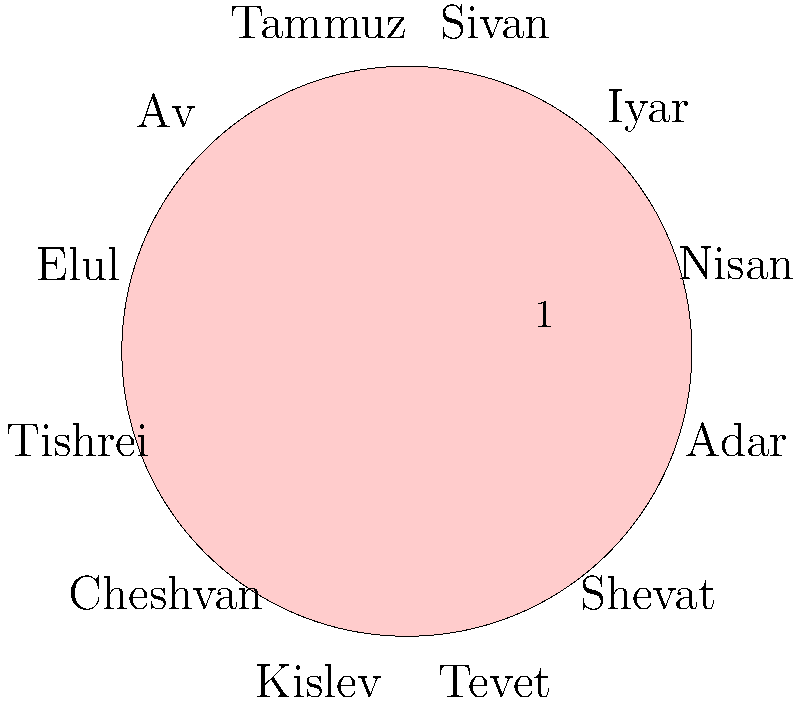According to the Hebrew calendar, which month is considered the first month of the year, and what is its spiritual significance in relation to the Exodus and our people's redemption? 1. The Hebrew calendar is based on lunar cycles and has 12 months in a regular year.

2. The first month of the Hebrew calendar is Nisan, which typically falls in March or April in the Gregorian calendar.

3. Nisan is highlighted in the circular calendar diagram, indicating its importance as the first month.

4. The spiritual significance of Nisan is deeply rooted in the history of the Israelites:
   a. It was during Nisan that the Exodus from Egypt occurred (Exodus 12:2-3).
   b. God commanded that Nisan be considered the first month of the year (Exodus 12:2).

5. The Exodus represents the redemption of our people from slavery and the beginning of our journey as a nation under God's guidance.

6. Nisan, therefore, symbolizes new beginnings, redemption, and the fulfillment of God's promises to His chosen people.

7. For Israel United in Christ, recognizing Nisan as the first month reinforces our connection to our Hebrew roots and the importance of following God's ordained calendar.

8. This understanding aligns with Bishop Nathanyel Ben Israel's teachings on returning to the true practices and beliefs of our forefathers.
Answer: Nisan; represents redemption and new beginnings for God's chosen people. 